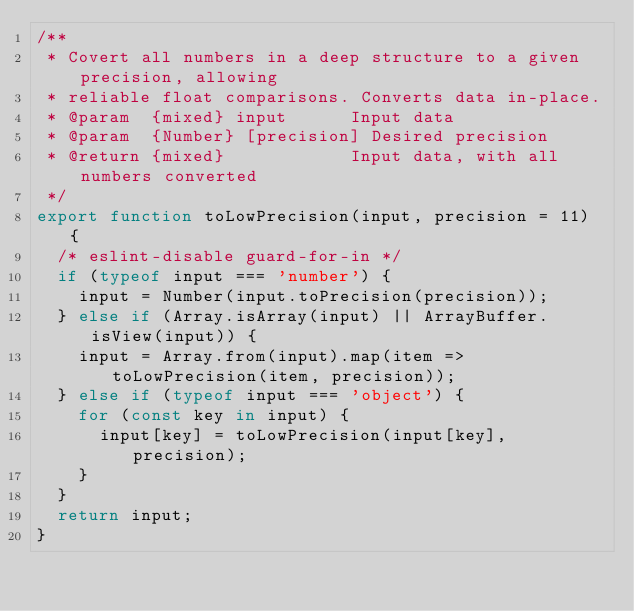<code> <loc_0><loc_0><loc_500><loc_500><_JavaScript_>/**
 * Covert all numbers in a deep structure to a given precision, allowing
 * reliable float comparisons. Converts data in-place.
 * @param  {mixed} input      Input data
 * @param  {Number} [precision] Desired precision
 * @return {mixed}            Input data, with all numbers converted
 */
export function toLowPrecision(input, precision = 11) {
  /* eslint-disable guard-for-in */
  if (typeof input === 'number') {
    input = Number(input.toPrecision(precision));
  } else if (Array.isArray(input) || ArrayBuffer.isView(input)) {
    input = Array.from(input).map(item => toLowPrecision(item, precision));
  } else if (typeof input === 'object') {
    for (const key in input) {
      input[key] = toLowPrecision(input[key], precision);
    }
  }
  return input;
}
</code> 